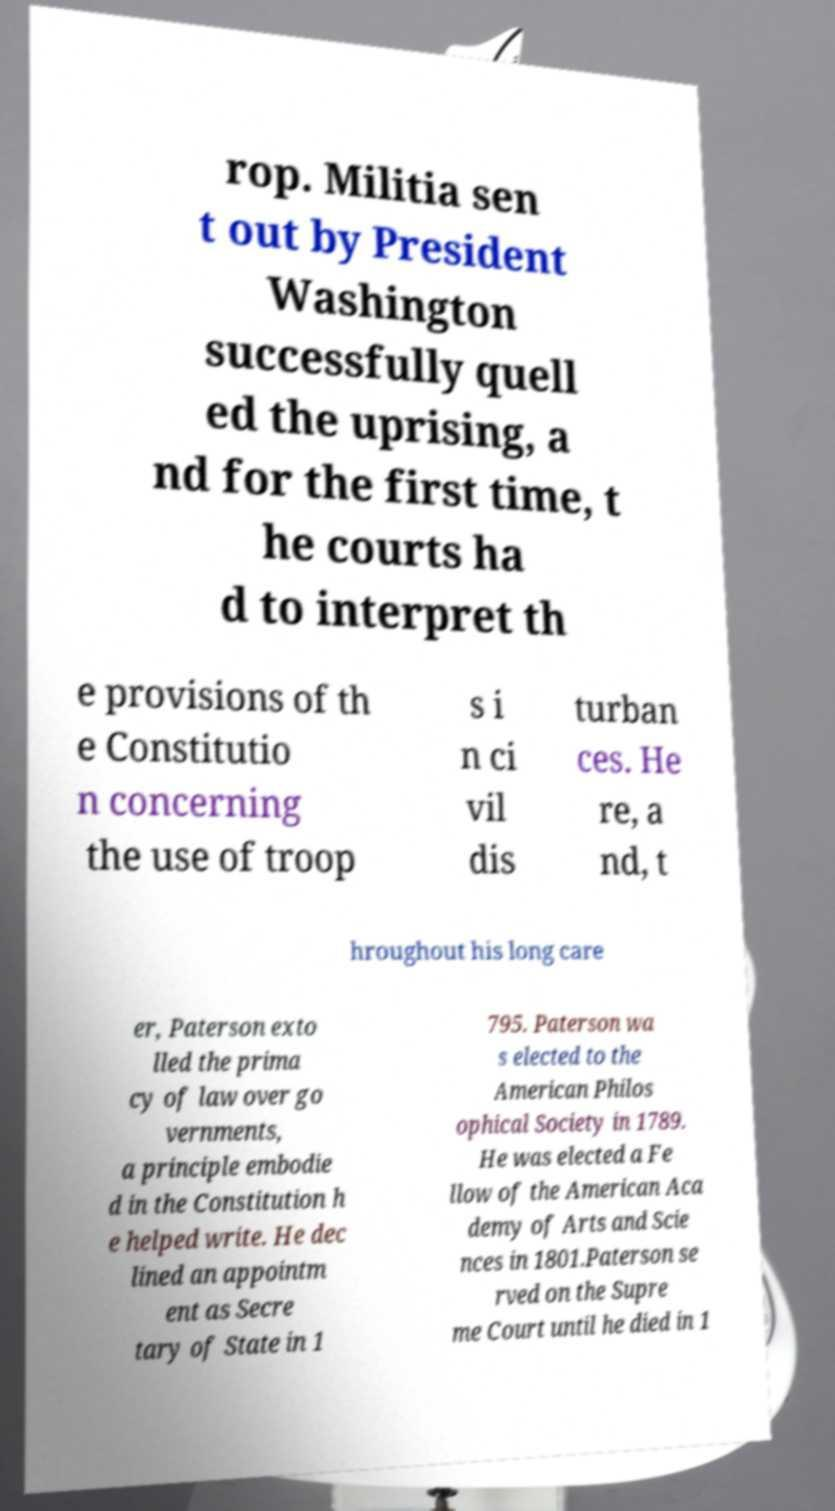Could you extract and type out the text from this image? rop. Militia sen t out by President Washington successfully quell ed the uprising, a nd for the first time, t he courts ha d to interpret th e provisions of th e Constitutio n concerning the use of troop s i n ci vil dis turban ces. He re, a nd, t hroughout his long care er, Paterson exto lled the prima cy of law over go vernments, a principle embodie d in the Constitution h e helped write. He dec lined an appointm ent as Secre tary of State in 1 795. Paterson wa s elected to the American Philos ophical Society in 1789. He was elected a Fe llow of the American Aca demy of Arts and Scie nces in 1801.Paterson se rved on the Supre me Court until he died in 1 